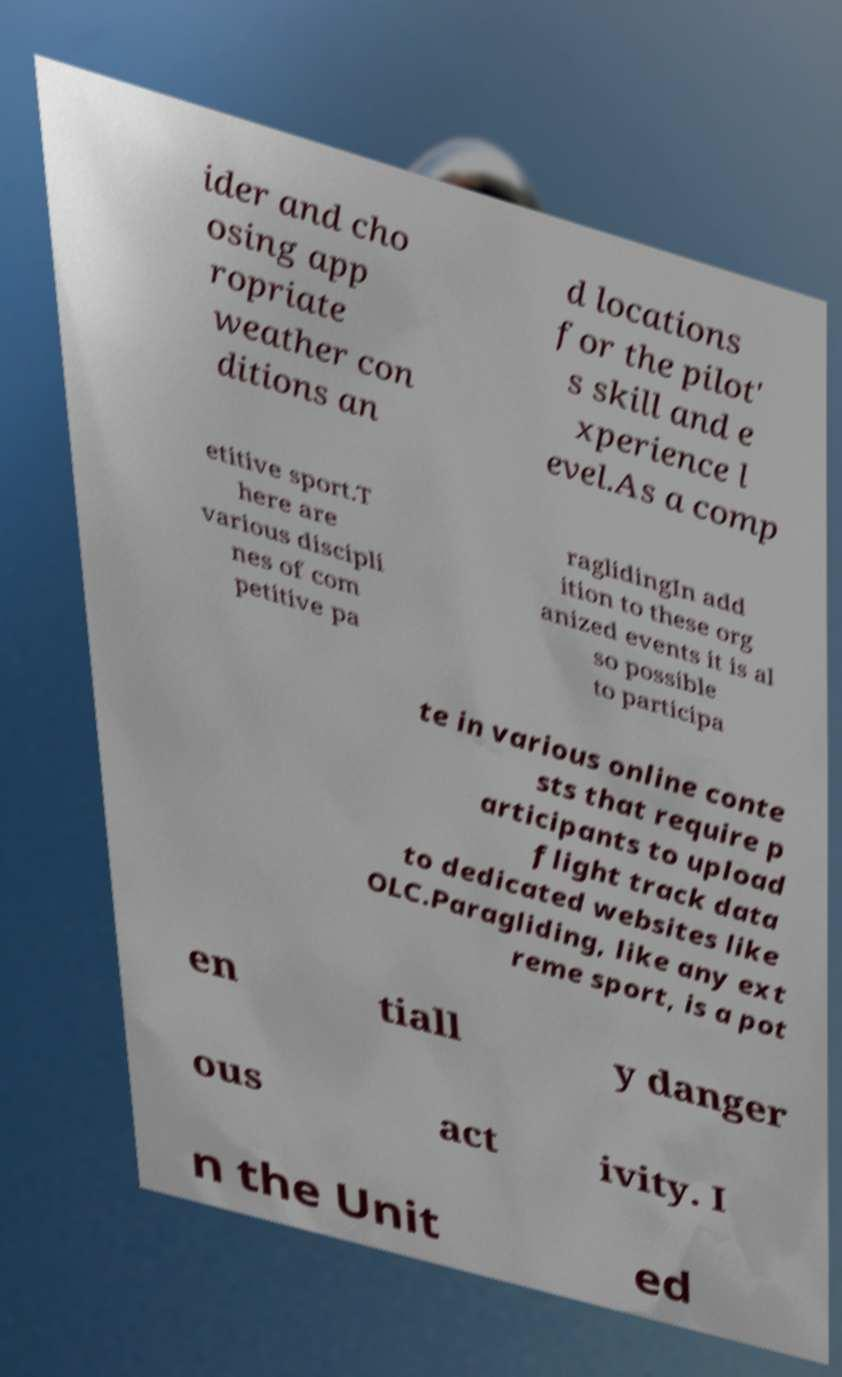Please identify and transcribe the text found in this image. ider and cho osing app ropriate weather con ditions an d locations for the pilot' s skill and e xperience l evel.As a comp etitive sport.T here are various discipli nes of com petitive pa raglidingIn add ition to these org anized events it is al so possible to participa te in various online conte sts that require p articipants to upload flight track data to dedicated websites like OLC.Paragliding, like any ext reme sport, is a pot en tiall y danger ous act ivity. I n the Unit ed 